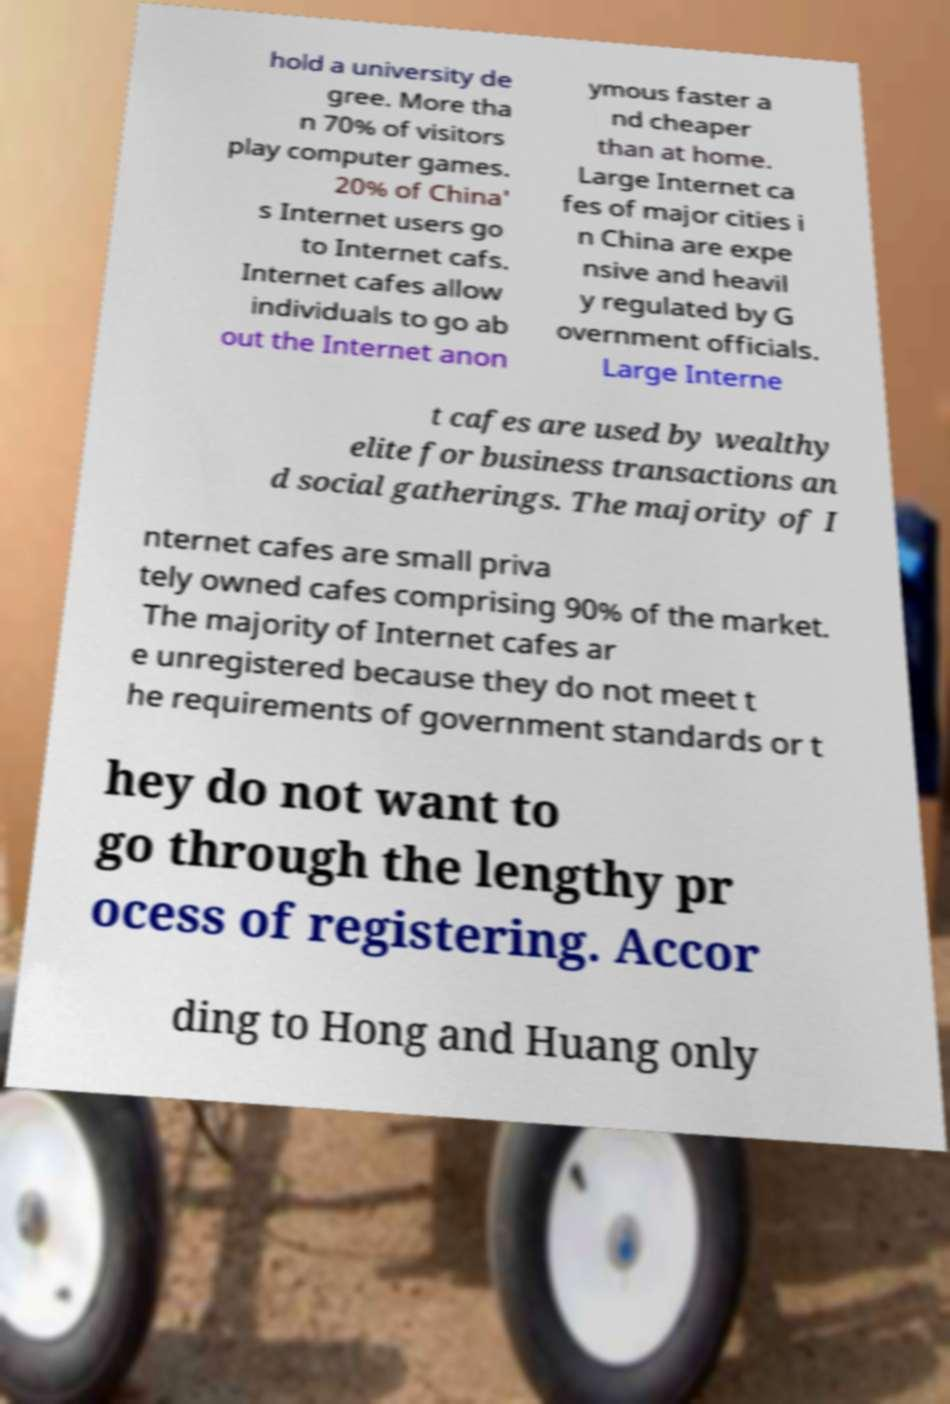Can you accurately transcribe the text from the provided image for me? hold a university de gree. More tha n 70% of visitors play computer games. 20% of China' s Internet users go to Internet cafs. Internet cafes allow individuals to go ab out the Internet anon ymous faster a nd cheaper than at home. Large Internet ca fes of major cities i n China are expe nsive and heavil y regulated by G overnment officials. Large Interne t cafes are used by wealthy elite for business transactions an d social gatherings. The majority of I nternet cafes are small priva tely owned cafes comprising 90% of the market. The majority of Internet cafes ar e unregistered because they do not meet t he requirements of government standards or t hey do not want to go through the lengthy pr ocess of registering. Accor ding to Hong and Huang only 